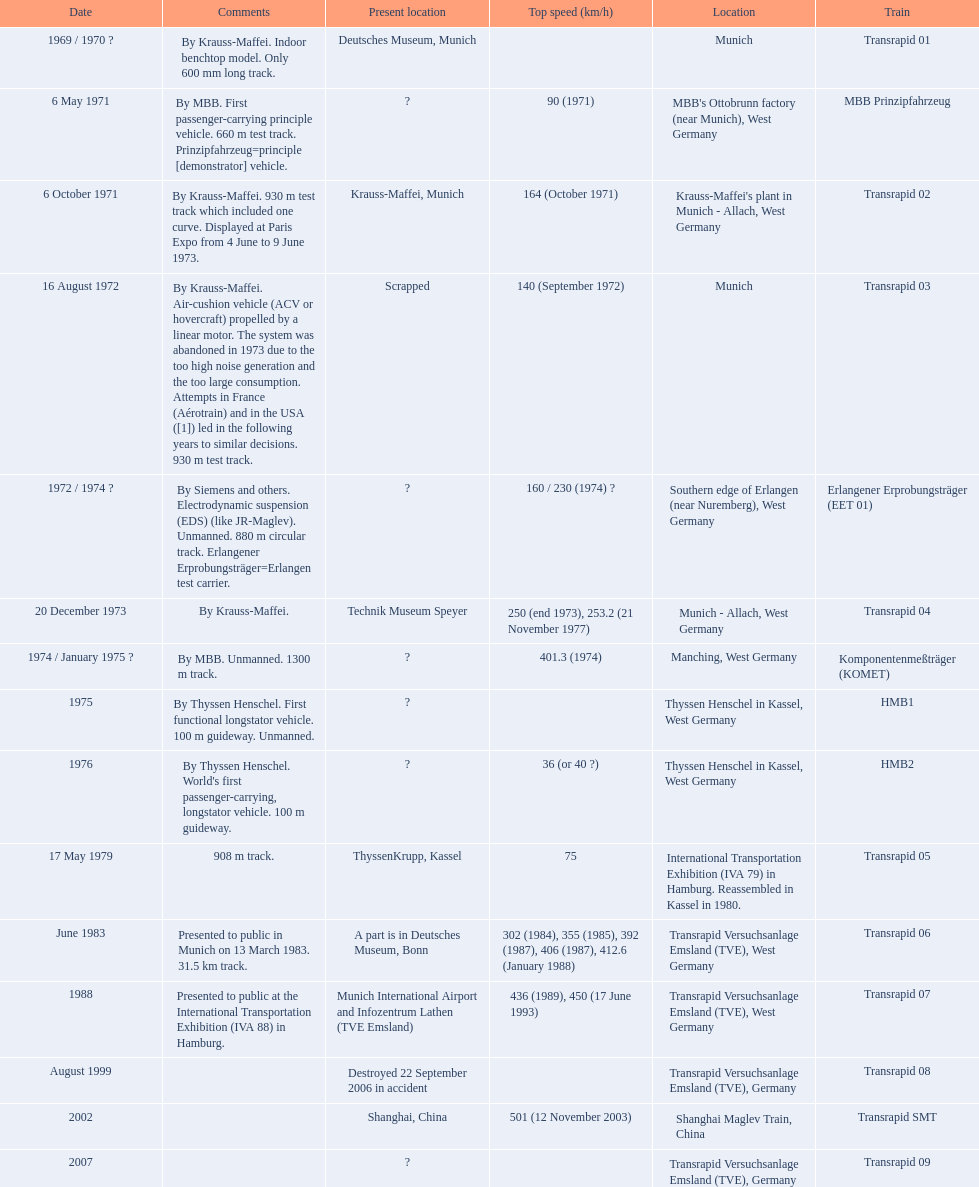What is the top speed reached by any trains shown here? 501 (12 November 2003). What train has reached a top speed of 501? Transrapid SMT. 